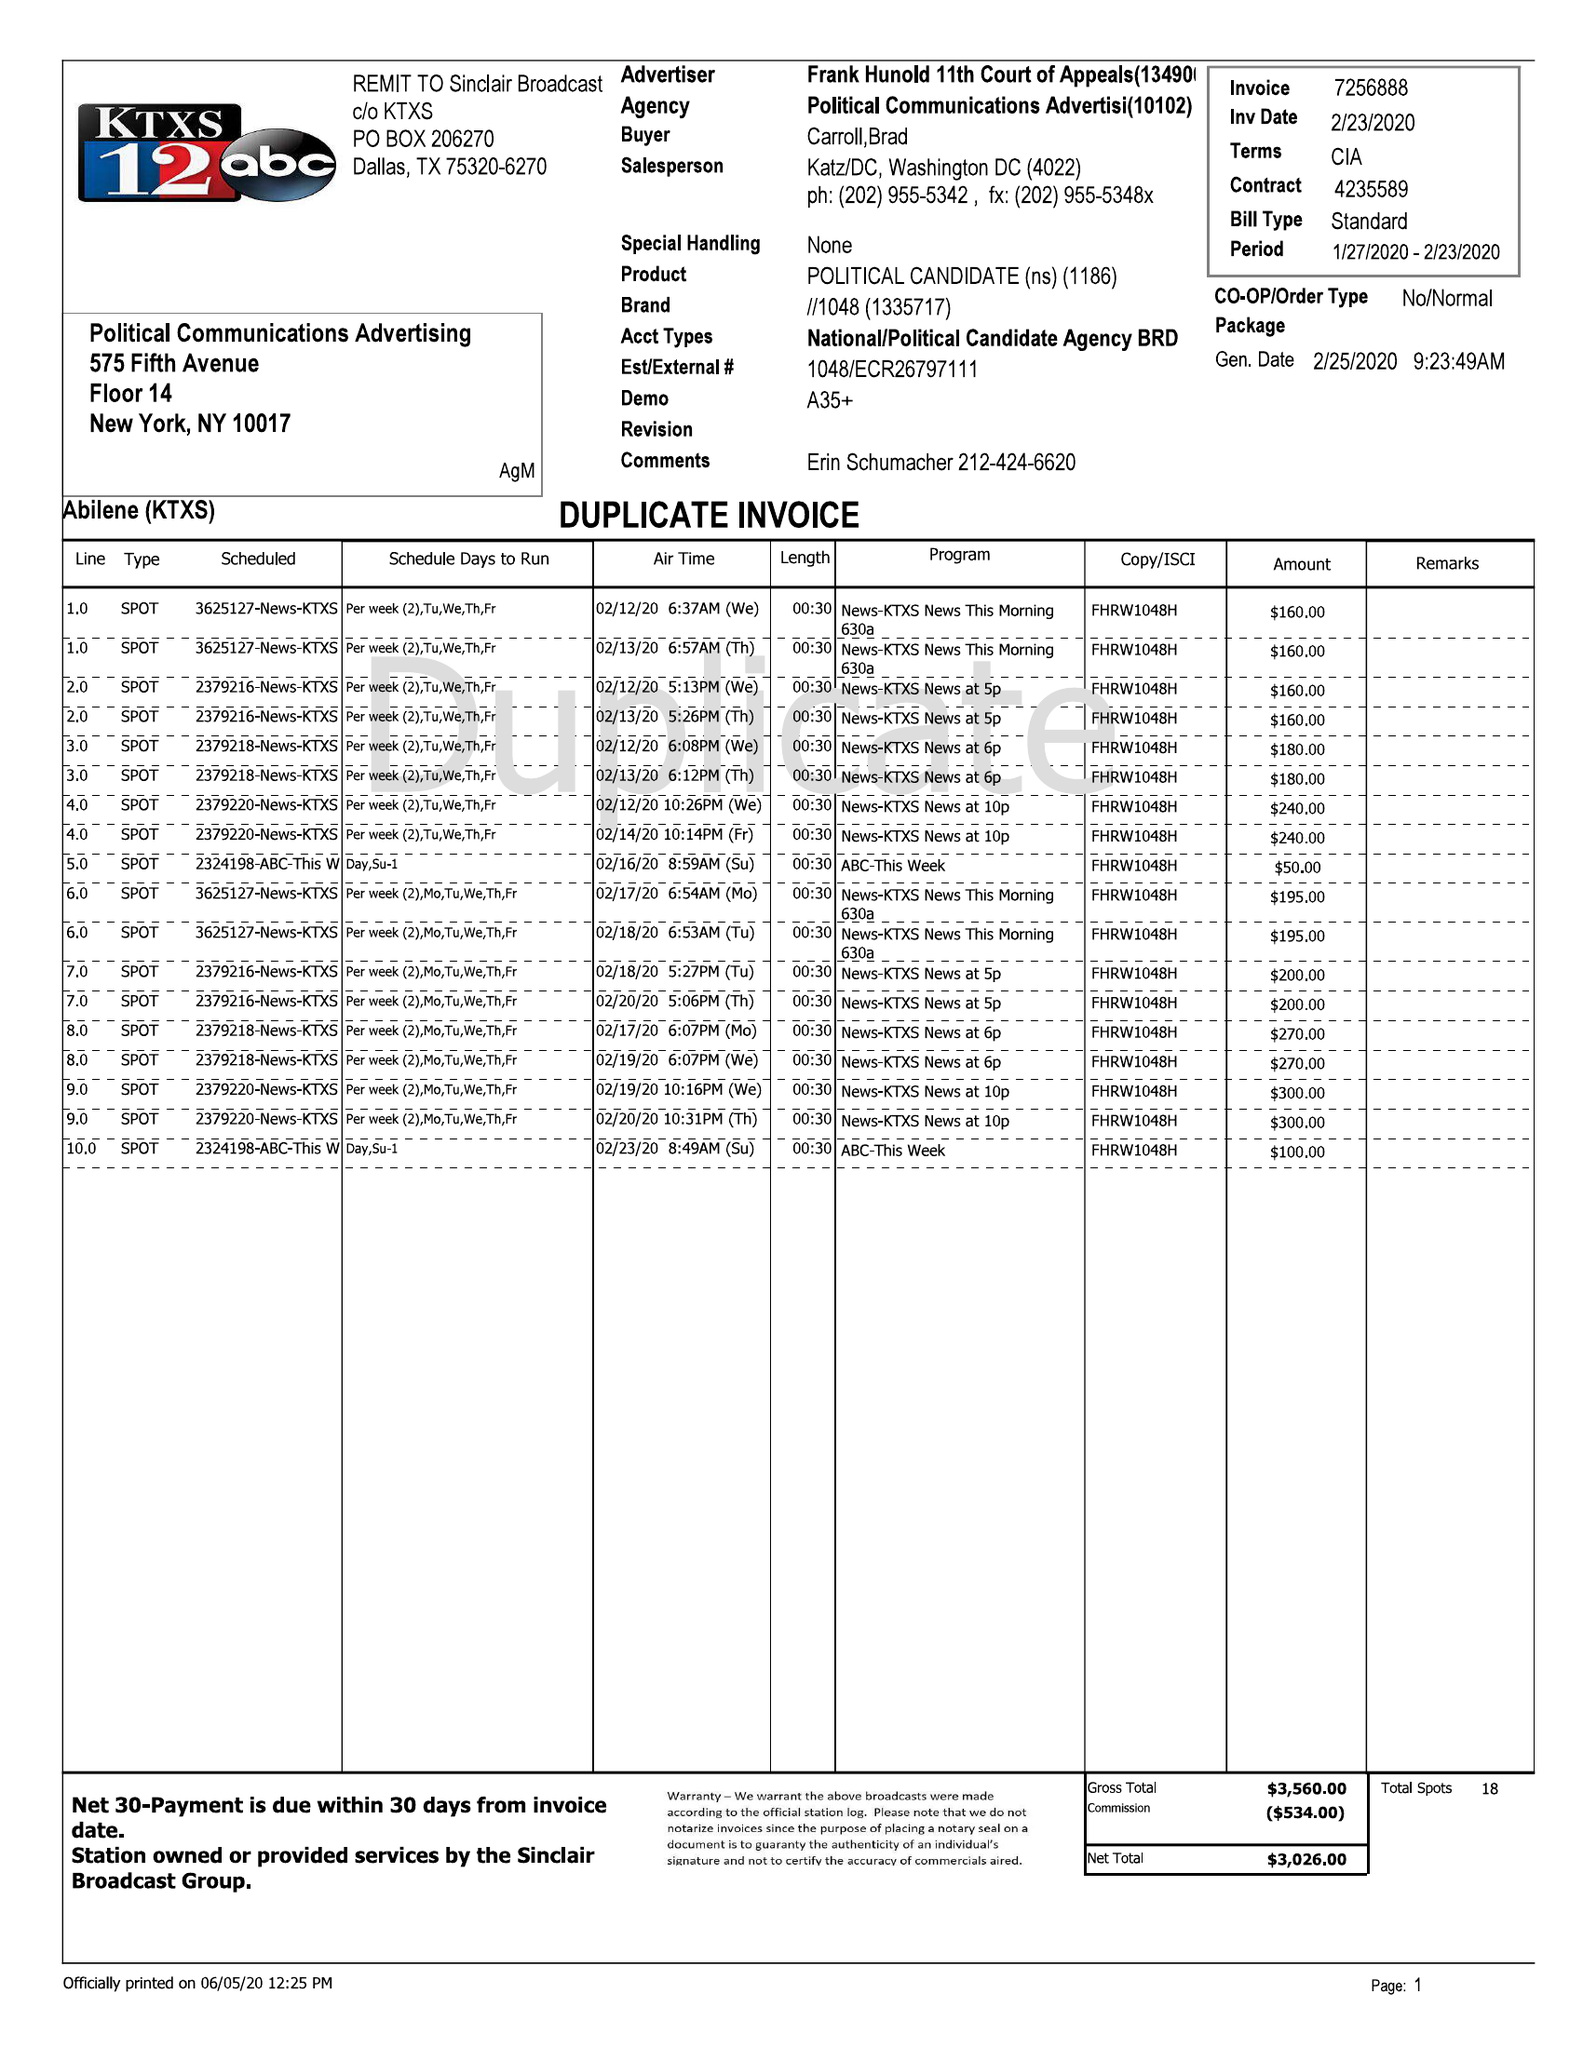What is the value for the gross_amount?
Answer the question using a single word or phrase. 5590.00 